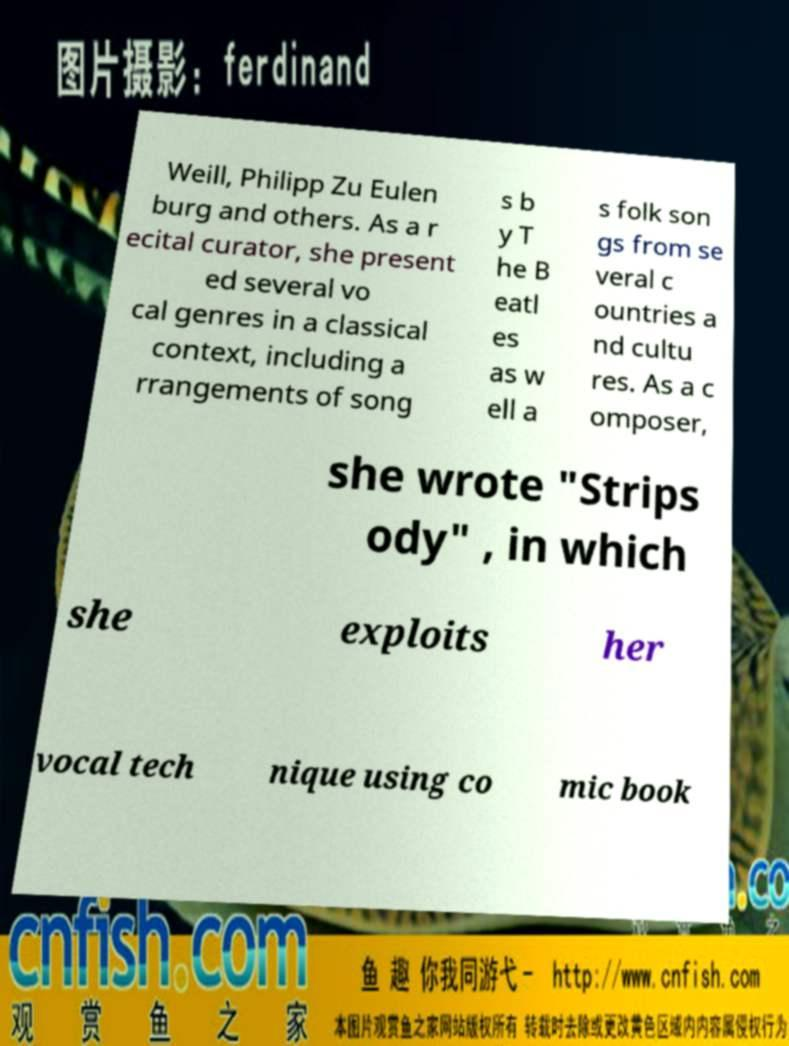Could you extract and type out the text from this image? Weill, Philipp Zu Eulen burg and others. As a r ecital curator, she present ed several vo cal genres in a classical context, including a rrangements of song s b y T he B eatl es as w ell a s folk son gs from se veral c ountries a nd cultu res. As a c omposer, she wrote "Strips ody" , in which she exploits her vocal tech nique using co mic book 